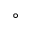Convert formula to latex. <formula><loc_0><loc_0><loc_500><loc_500>^ { \circ }</formula> 